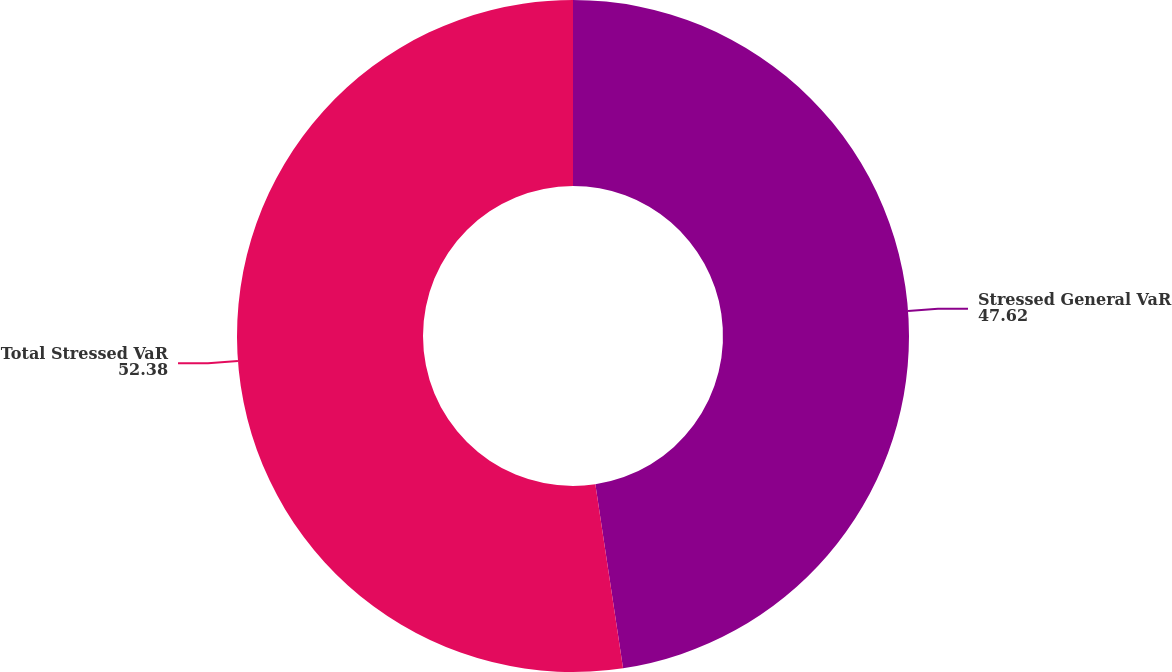<chart> <loc_0><loc_0><loc_500><loc_500><pie_chart><fcel>Stressed General VaR<fcel>Total Stressed VaR<nl><fcel>47.62%<fcel>52.38%<nl></chart> 